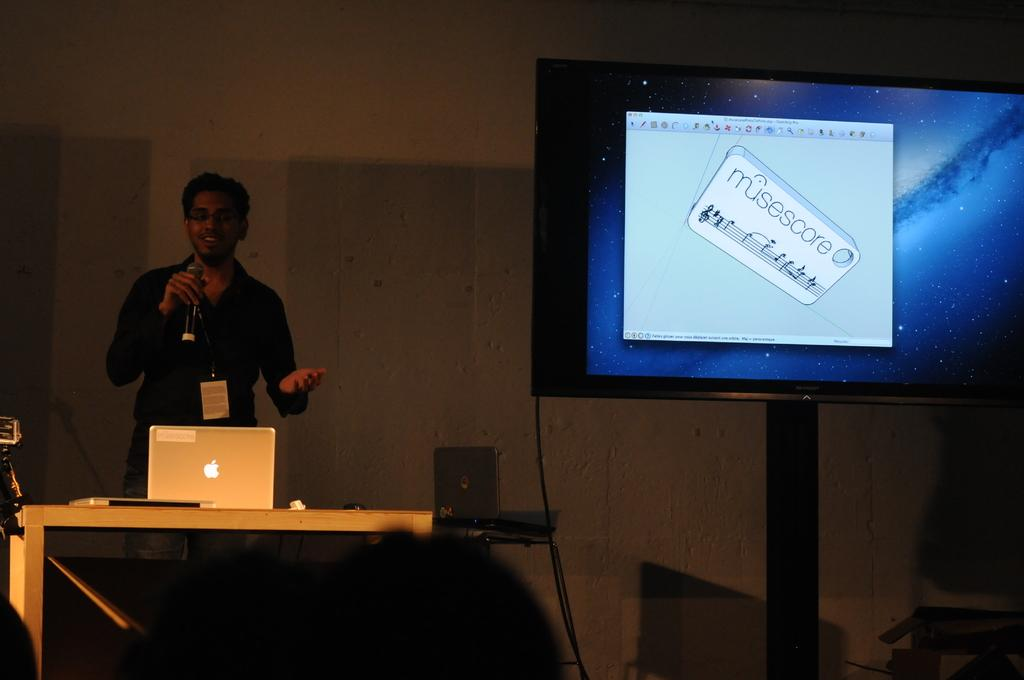What is the man in the image doing? The man is standing in the image and holding a mic in his hand. What objects are on the table in the image? There is a laptop and another laptop on the table in the image. What can be seen on the screen in the image? There is a screen in the image, but the content is not specified. What other object is present in the image? There is a box in the image. What type of soup is being served in the image? There is no soup present in the image. What nation is represented by the board in the image? There is no board present in the image. 